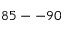Convert formula to latex. <formula><loc_0><loc_0><loc_500><loc_500>8 5 - - 9 0</formula> 